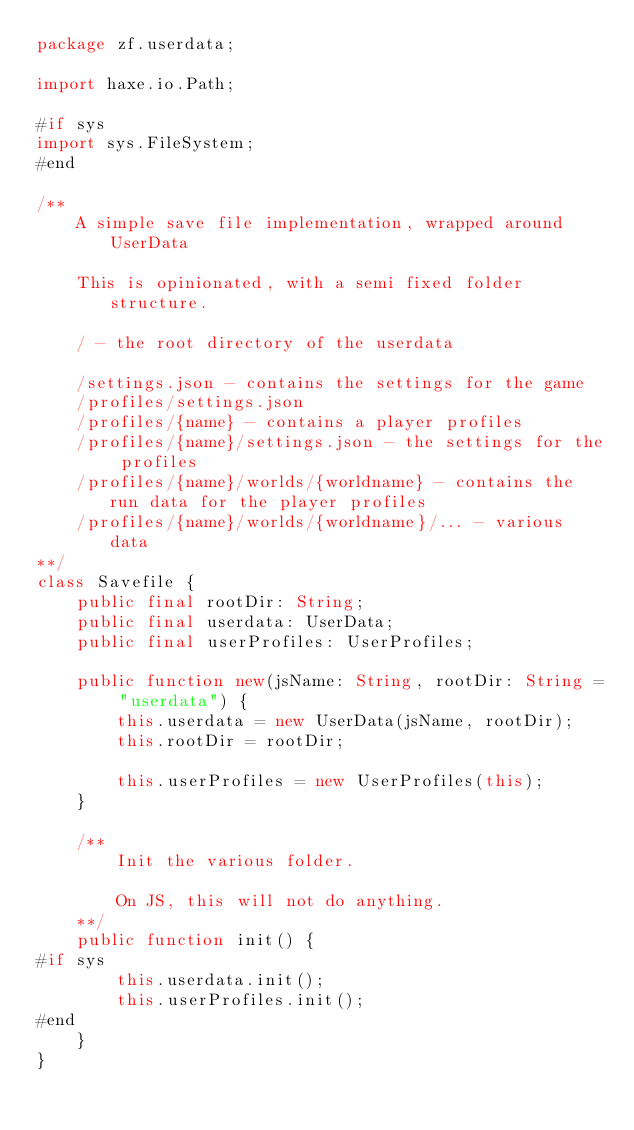Convert code to text. <code><loc_0><loc_0><loc_500><loc_500><_Haxe_>package zf.userdata;

import haxe.io.Path;

#if sys
import sys.FileSystem;
#end

/**
	A simple save file implementation, wrapped around UserData

	This is opinionated, with a semi fixed folder structure.

	/ - the root directory of the userdata

	/settings.json - contains the settings for the game
	/profiles/settings.json
	/profiles/{name} - contains a player profiles
	/profiles/{name}/settings.json - the settings for the profiles
	/profiles/{name}/worlds/{worldname} - contains the run data for the player profiles
	/profiles/{name}/worlds/{worldname}/... - various data
**/
class Savefile {
	public final rootDir: String;
	public final userdata: UserData;
	public final userProfiles: UserProfiles;

	public function new(jsName: String, rootDir: String = "userdata") {
		this.userdata = new UserData(jsName, rootDir);
		this.rootDir = rootDir;

		this.userProfiles = new UserProfiles(this);
	}

	/**
		Init the various folder.

		On JS, this will not do anything.
	**/
	public function init() {
#if sys
		this.userdata.init();
		this.userProfiles.init();
#end
	}
}
</code> 